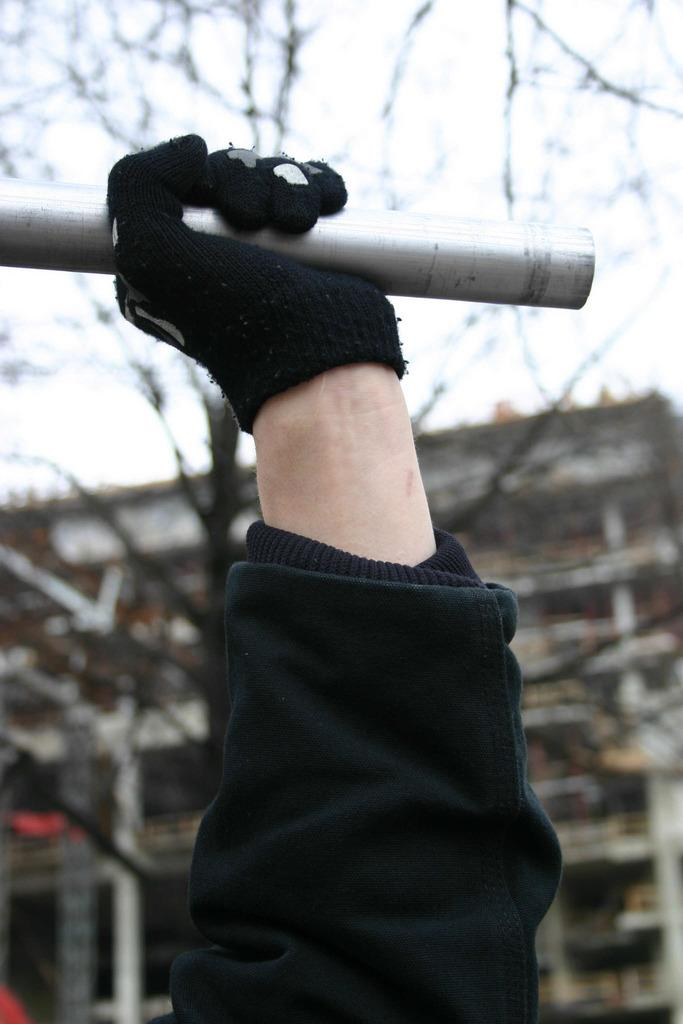What is the focus of the image? The image is zoomed in on a hand. What can be observed about the hand in the image? The hand is wearing a black color glove and is holding a metal rod. What is visible in the background of the image? There is a building and the sky visible in the background of the image. How does the hand in the image sort the minute particles? There are no minute particles present in the image, and the hand is not shown sorting anything. 